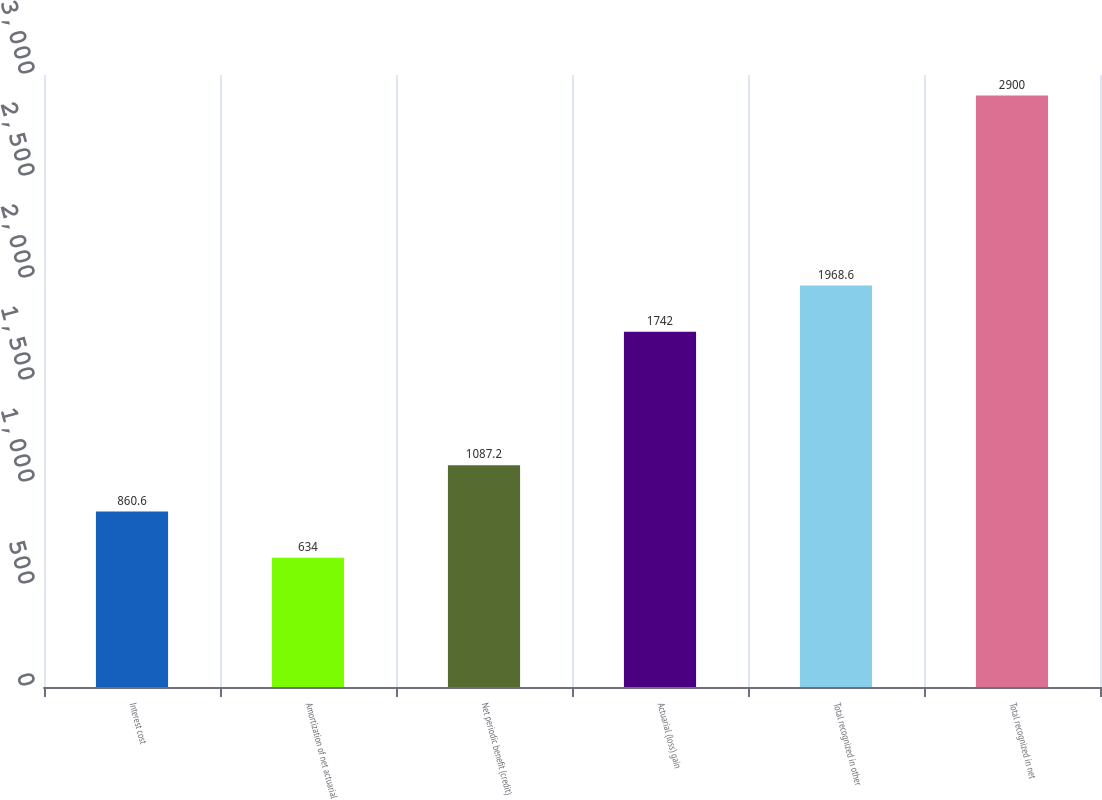Convert chart. <chart><loc_0><loc_0><loc_500><loc_500><bar_chart><fcel>Interest cost<fcel>Amortization of net actuarial<fcel>Net periodic benefit (credit)<fcel>Actuarial (loss) gain<fcel>Total recognized in other<fcel>Total recognized in net<nl><fcel>860.6<fcel>634<fcel>1087.2<fcel>1742<fcel>1968.6<fcel>2900<nl></chart> 